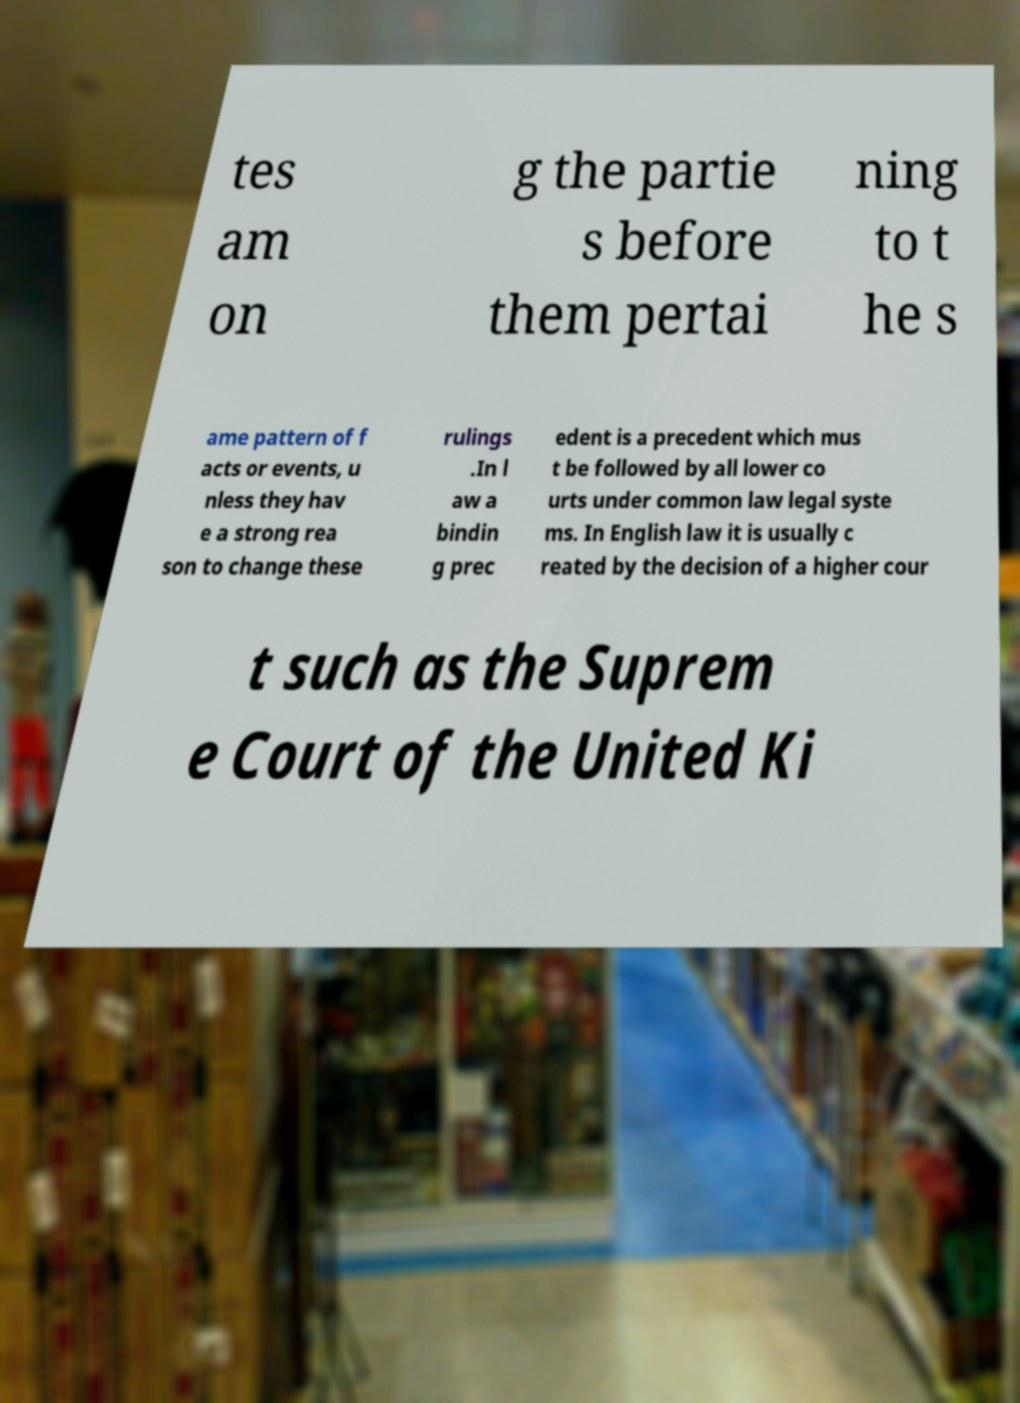Please identify and transcribe the text found in this image. tes am on g the partie s before them pertai ning to t he s ame pattern of f acts or events, u nless they hav e a strong rea son to change these rulings .In l aw a bindin g prec edent is a precedent which mus t be followed by all lower co urts under common law legal syste ms. In English law it is usually c reated by the decision of a higher cour t such as the Suprem e Court of the United Ki 